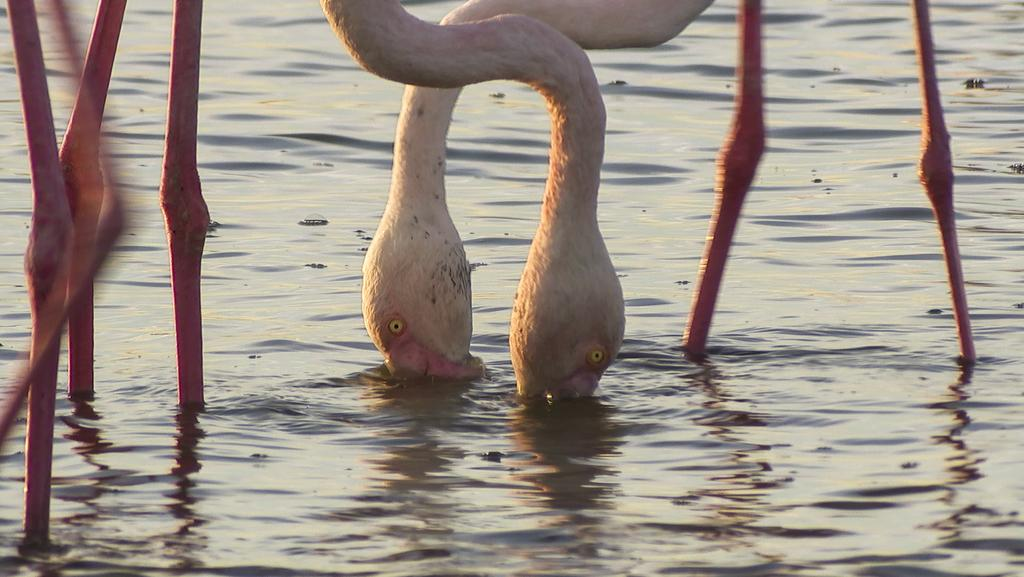What type of animals are in the water in the image? There are cranes (birds) in the water in the image. Where are the cranes located in relation to the image? The cranes are in the foreground of the image. What is the limit of the selection of bridges in the image? There are no bridges present in the image, so it is not possible to determine a limit or selection of bridges. 